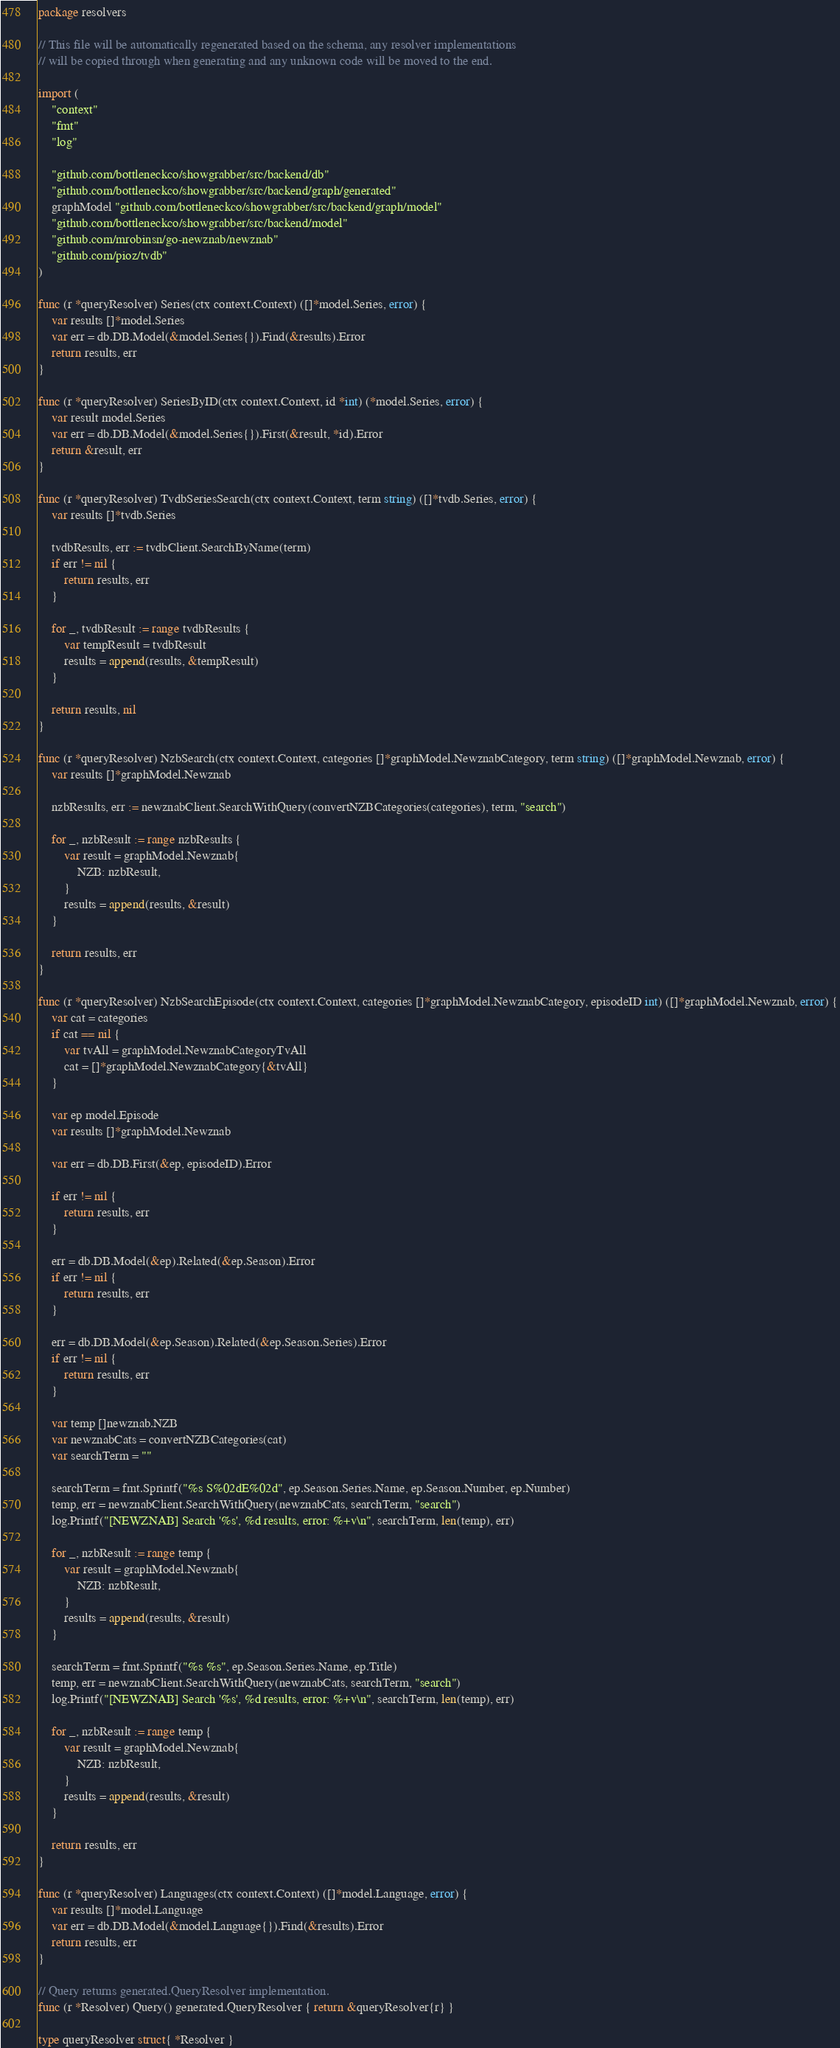<code> <loc_0><loc_0><loc_500><loc_500><_Go_>package resolvers

// This file will be automatically regenerated based on the schema, any resolver implementations
// will be copied through when generating and any unknown code will be moved to the end.

import (
	"context"
	"fmt"
	"log"

	"github.com/bottleneckco/showgrabber/src/backend/db"
	"github.com/bottleneckco/showgrabber/src/backend/graph/generated"
	graphModel "github.com/bottleneckco/showgrabber/src/backend/graph/model"
	"github.com/bottleneckco/showgrabber/src/backend/model"
	"github.com/mrobinsn/go-newznab/newznab"
	"github.com/pioz/tvdb"
)

func (r *queryResolver) Series(ctx context.Context) ([]*model.Series, error) {
	var results []*model.Series
	var err = db.DB.Model(&model.Series{}).Find(&results).Error
	return results, err
}

func (r *queryResolver) SeriesByID(ctx context.Context, id *int) (*model.Series, error) {
	var result model.Series
	var err = db.DB.Model(&model.Series{}).First(&result, *id).Error
	return &result, err
}

func (r *queryResolver) TvdbSeriesSearch(ctx context.Context, term string) ([]*tvdb.Series, error) {
	var results []*tvdb.Series

	tvdbResults, err := tvdbClient.SearchByName(term)
	if err != nil {
		return results, err
	}

	for _, tvdbResult := range tvdbResults {
		var tempResult = tvdbResult
		results = append(results, &tempResult)
	}

	return results, nil
}

func (r *queryResolver) NzbSearch(ctx context.Context, categories []*graphModel.NewznabCategory, term string) ([]*graphModel.Newznab, error) {
	var results []*graphModel.Newznab

	nzbResults, err := newznabClient.SearchWithQuery(convertNZBCategories(categories), term, "search")

	for _, nzbResult := range nzbResults {
		var result = graphModel.Newznab{
			NZB: nzbResult,
		}
		results = append(results, &result)
	}

	return results, err
}

func (r *queryResolver) NzbSearchEpisode(ctx context.Context, categories []*graphModel.NewznabCategory, episodeID int) ([]*graphModel.Newznab, error) {
	var cat = categories
	if cat == nil {
		var tvAll = graphModel.NewznabCategoryTvAll
		cat = []*graphModel.NewznabCategory{&tvAll}
	}

	var ep model.Episode
	var results []*graphModel.Newznab

	var err = db.DB.First(&ep, episodeID).Error

	if err != nil {
		return results, err
	}

	err = db.DB.Model(&ep).Related(&ep.Season).Error
	if err != nil {
		return results, err
	}

	err = db.DB.Model(&ep.Season).Related(&ep.Season.Series).Error
	if err != nil {
		return results, err
	}

	var temp []newznab.NZB
	var newznabCats = convertNZBCategories(cat)
	var searchTerm = ""

	searchTerm = fmt.Sprintf("%s S%02dE%02d", ep.Season.Series.Name, ep.Season.Number, ep.Number)
	temp, err = newznabClient.SearchWithQuery(newznabCats, searchTerm, "search")
	log.Printf("[NEWZNAB] Search '%s', %d results, error: %+v\n", searchTerm, len(temp), err)

	for _, nzbResult := range temp {
		var result = graphModel.Newznab{
			NZB: nzbResult,
		}
		results = append(results, &result)
	}

	searchTerm = fmt.Sprintf("%s %s", ep.Season.Series.Name, ep.Title)
	temp, err = newznabClient.SearchWithQuery(newznabCats, searchTerm, "search")
	log.Printf("[NEWZNAB] Search '%s', %d results, error: %+v\n", searchTerm, len(temp), err)

	for _, nzbResult := range temp {
		var result = graphModel.Newznab{
			NZB: nzbResult,
		}
		results = append(results, &result)
	}

	return results, err
}

func (r *queryResolver) Languages(ctx context.Context) ([]*model.Language, error) {
	var results []*model.Language
	var err = db.DB.Model(&model.Language{}).Find(&results).Error
	return results, err
}

// Query returns generated.QueryResolver implementation.
func (r *Resolver) Query() generated.QueryResolver { return &queryResolver{r} }

type queryResolver struct{ *Resolver }
</code> 